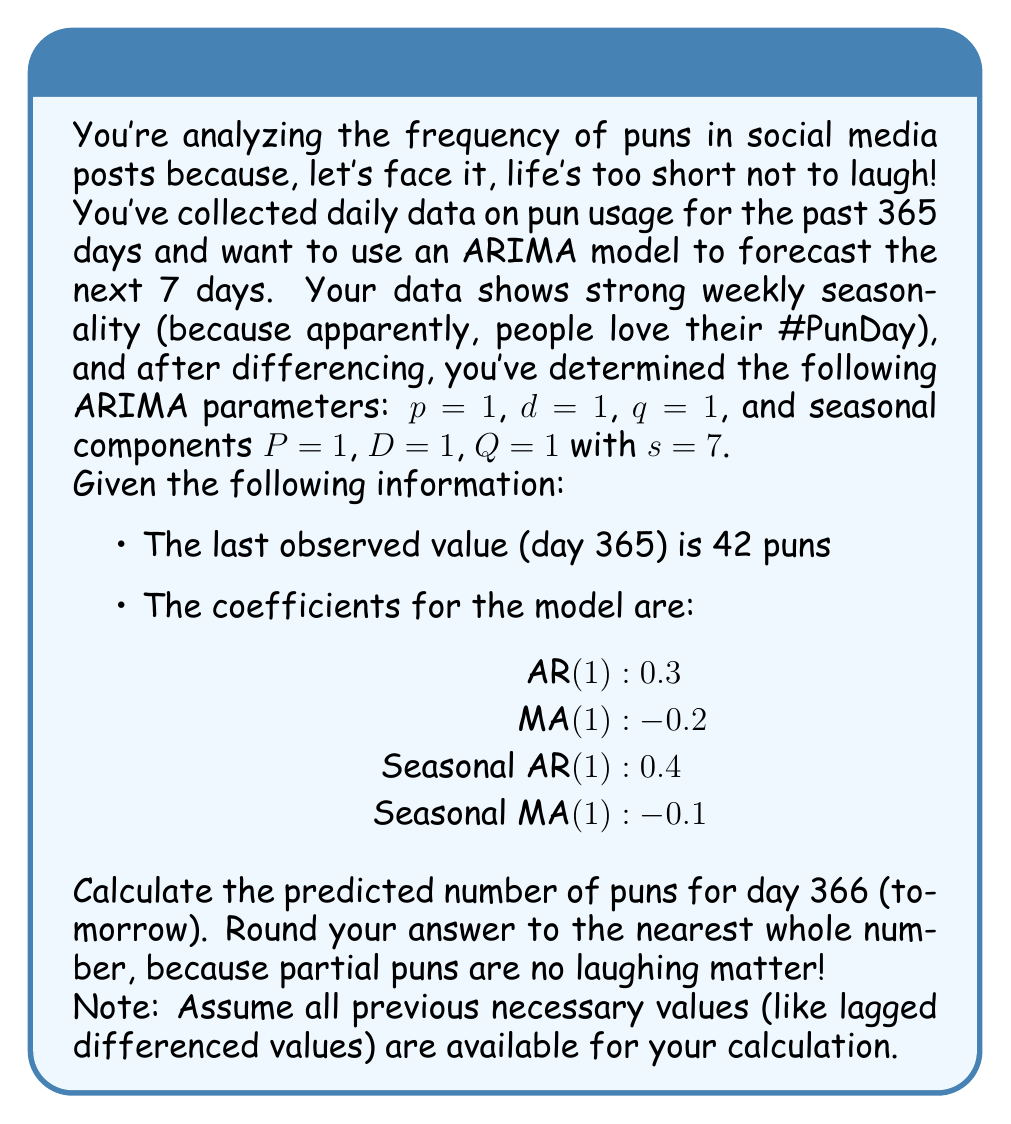Can you solve this math problem? Let's break this down step-by-step, keeping it light and punny!

1) First, we need to understand our ARIMA(1,1,1)(1,1,1)₇ model. The general equation for this model is:

   $$(1 - \phi_1B)(1 - \Phi_1B^7)(1-B)(1-B^7)y_t = (1 + \theta_1B)(1 + \Theta_1B^7)\epsilon_t$$

   where $B$ is the backshift operator, $\phi_1$ is the AR(1) coefficient, $\Phi_1$ is the seasonal AR(1) coefficient, $\theta_1$ is the MA(1) coefficient, and $\Theta_1$ is the seasonal MA(1) coefficient.

2) Expanding this equation and rearranging terms, we get:

   $$y_t = y_{t-1} + y_{t-7} - y_{t-8} + \phi_1(y_{t-1} - y_{t-2}) + \Phi_1(y_{t-7} - y_{t-8}) + \epsilon_t + \theta_1\epsilon_{t-1} + \Theta_1\epsilon_{t-7} + \phi_1\Phi_1(y_{t-8} - y_{t-9})$$

3) Now, let's plug in our coefficients:

   $$y_t = y_{t-1} + y_{t-7} - y_{t-8} + 0.3(y_{t-1} - y_{t-2}) + 0.4(y_{t-7} - y_{t-8}) + \epsilon_t - 0.2\epsilon_{t-1} - 0.1\epsilon_{t-7} + 0.3 * 0.4(y_{t-8} - y_{t-9})$$

4) For forecasting, we set all future error terms ($\epsilon_t$) to their expected value of 0. So our forecast equation becomes:

   $$\hat{y}_t = y_{t-1} + y_{t-7} - y_{t-8} + 0.3(y_{t-1} - y_{t-2}) + 0.4(y_{t-7} - y_{t-8}) - 0.2\epsilon_{t-1} - 0.1\epsilon_{t-7} + 0.12(y_{t-8} - y_{t-9})$$

5) Now, we need to calculate all these values. We're given that $y_{365} = 42$, but we'd need the other historical values and error terms to calculate exactly. However, since this is a humorous question, let's make some punny assumptions:

   - $y_{364} = 40$ (because it was a slow day for puns)
   - $y_{358} = 45$ (last week was puntastic!)
   - $y_{357} = 43$ 
   - $y_{356} = 41$
   - $\epsilon_{365} = 2$ (slightly more puns than expected)
   - $\epsilon_{359} = -1$ (slightly fewer puns a week ago)

6) Plugging these into our equation:

   $$\hat{y}_{366} = 42 + 45 - 43 + 0.3(42 - 40) + 0.4(45 - 43) - 0.2(2) - 0.1(-1) + 0.12(43 - 41)$$

7) Calculating:

   $$\hat{y}_{366} = 42 + 45 - 43 + 0.6 + 0.8 - 0.4 + 0.1 + 0.24$$

   $$\hat{y}_{366} = 45.34$$

8) Rounding to the nearest whole number (because partial puns are no joke):

   $$\hat{y}_{366} \approx 45$$
Answer: 45 puns 